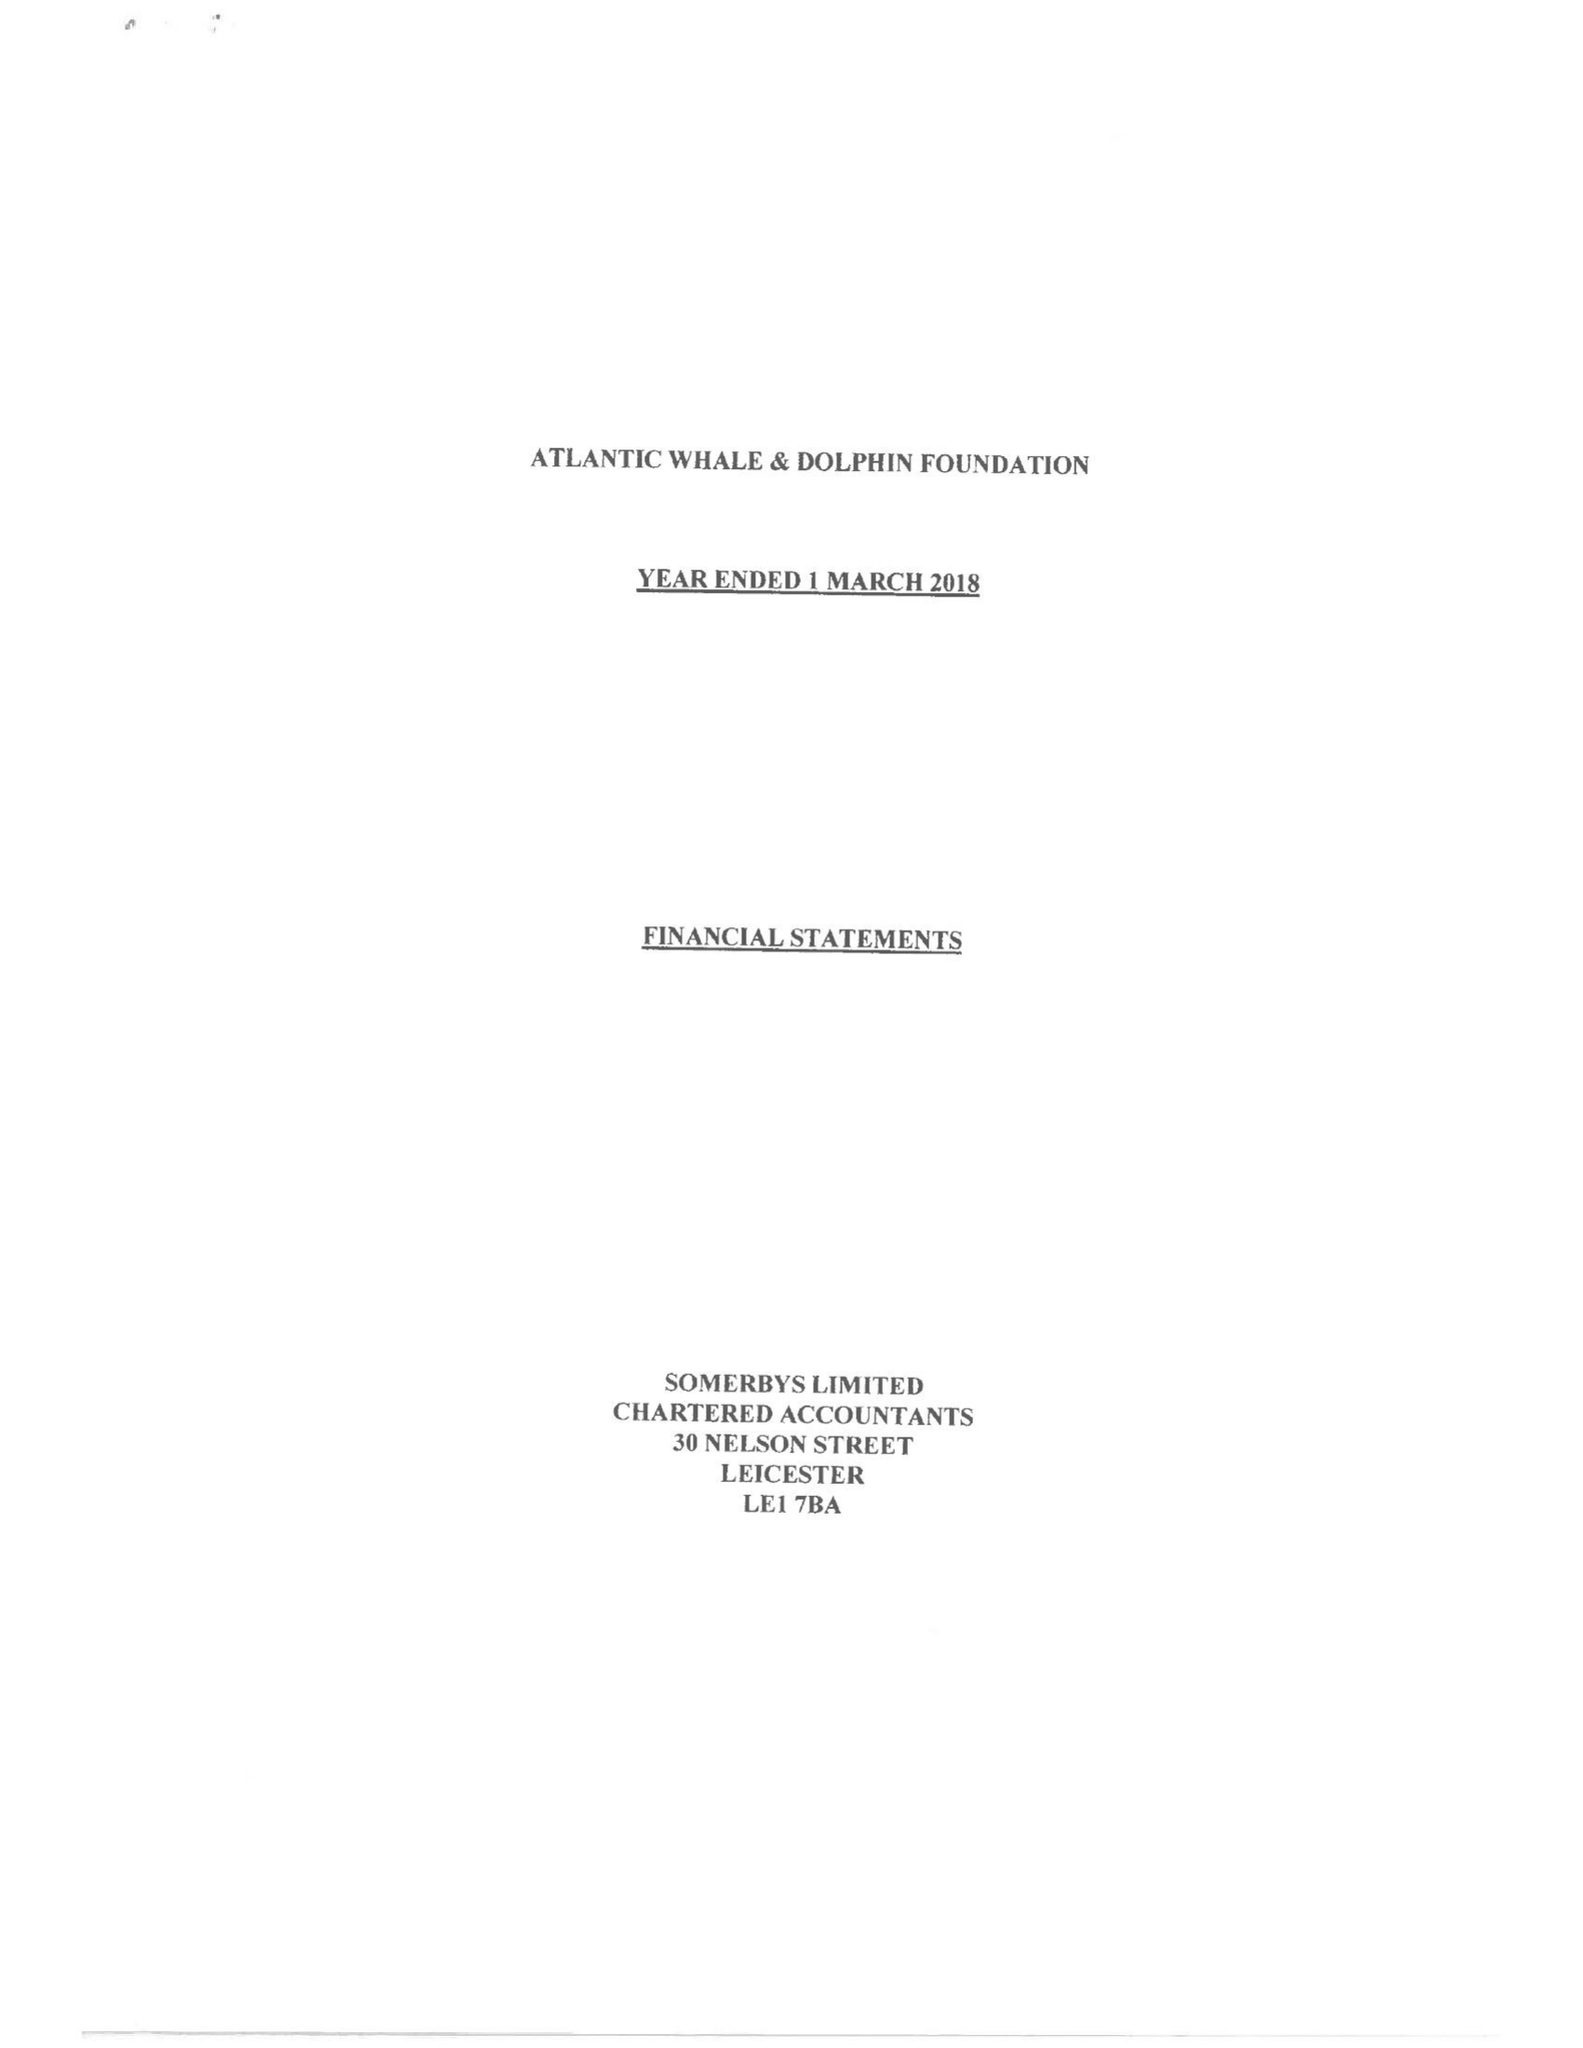What is the value for the income_annually_in_british_pounds?
Answer the question using a single word or phrase. 163492.00 